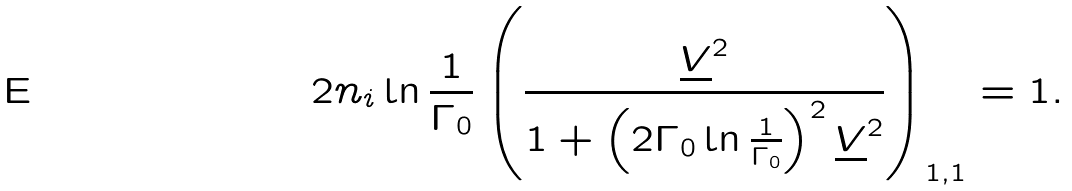<formula> <loc_0><loc_0><loc_500><loc_500>2 n _ { i } \ln \frac { 1 } { \Gamma _ { 0 } } \left ( \frac { \underline { V } ^ { 2 } } { 1 + \left ( 2 \Gamma _ { 0 } \ln \frac { 1 } { \Gamma _ { 0 } } \right ) ^ { 2 } \underline { V } ^ { 2 } } \right ) _ { 1 , 1 } = 1 .</formula> 